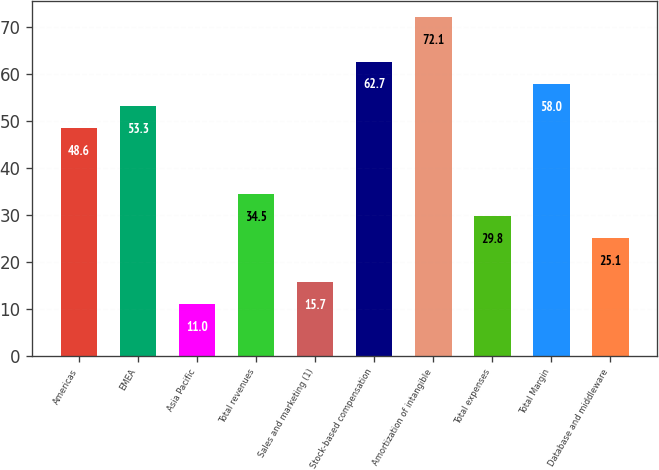<chart> <loc_0><loc_0><loc_500><loc_500><bar_chart><fcel>Americas<fcel>EMEA<fcel>Asia Pacific<fcel>Total revenues<fcel>Sales and marketing (1)<fcel>Stock-based compensation<fcel>Amortization of intangible<fcel>Total expenses<fcel>Total Margin<fcel>Database and middleware<nl><fcel>48.6<fcel>53.3<fcel>11<fcel>34.5<fcel>15.7<fcel>62.7<fcel>72.1<fcel>29.8<fcel>58<fcel>25.1<nl></chart> 